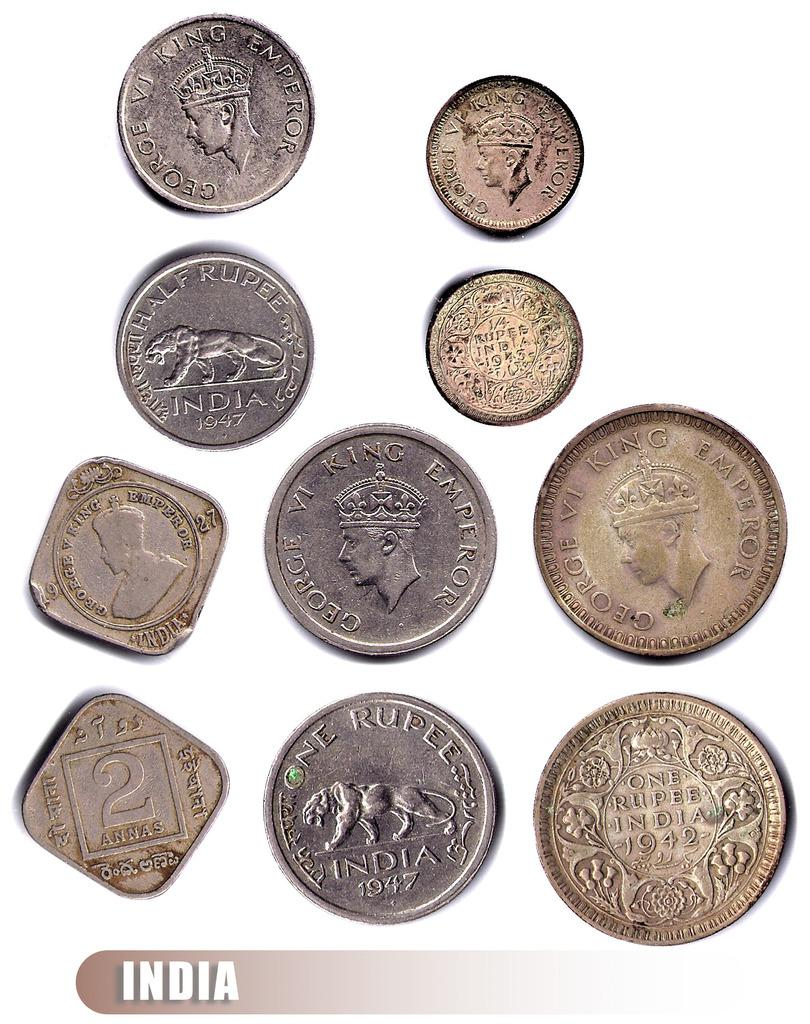<image>
Describe the image concisely. A collection of coins from India, many with the word India and their denomination on them. 